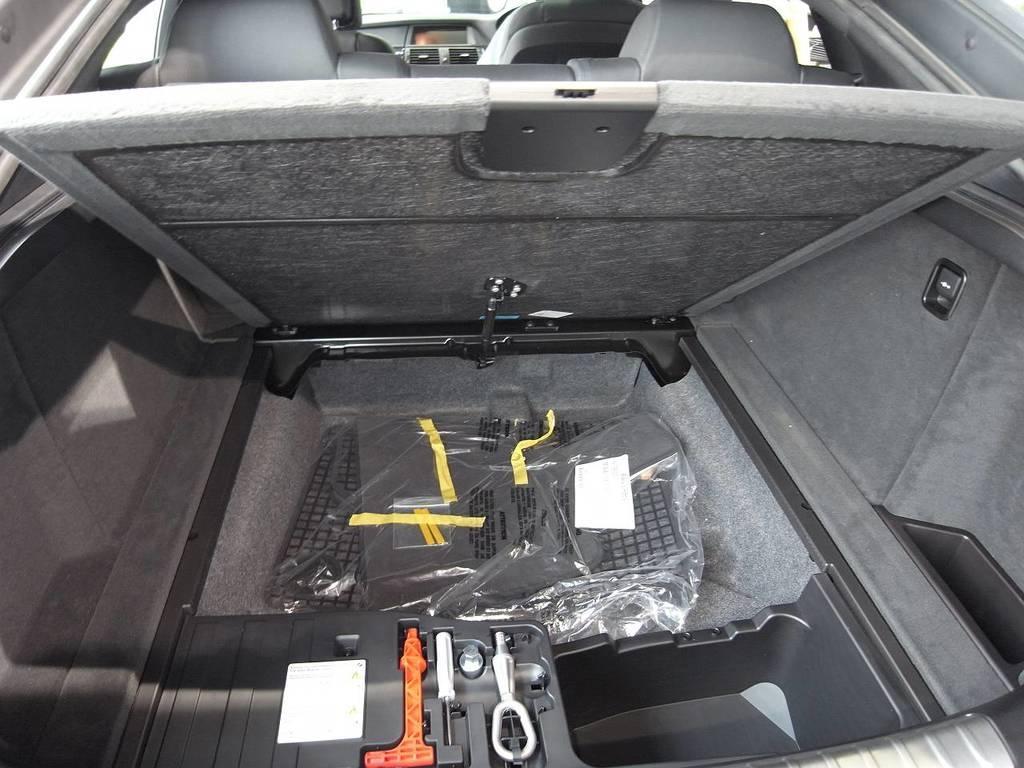Please provide a concise description of this image. This is the internal picture of the car. In this image we can see seats and some tools in the boot of the car. 